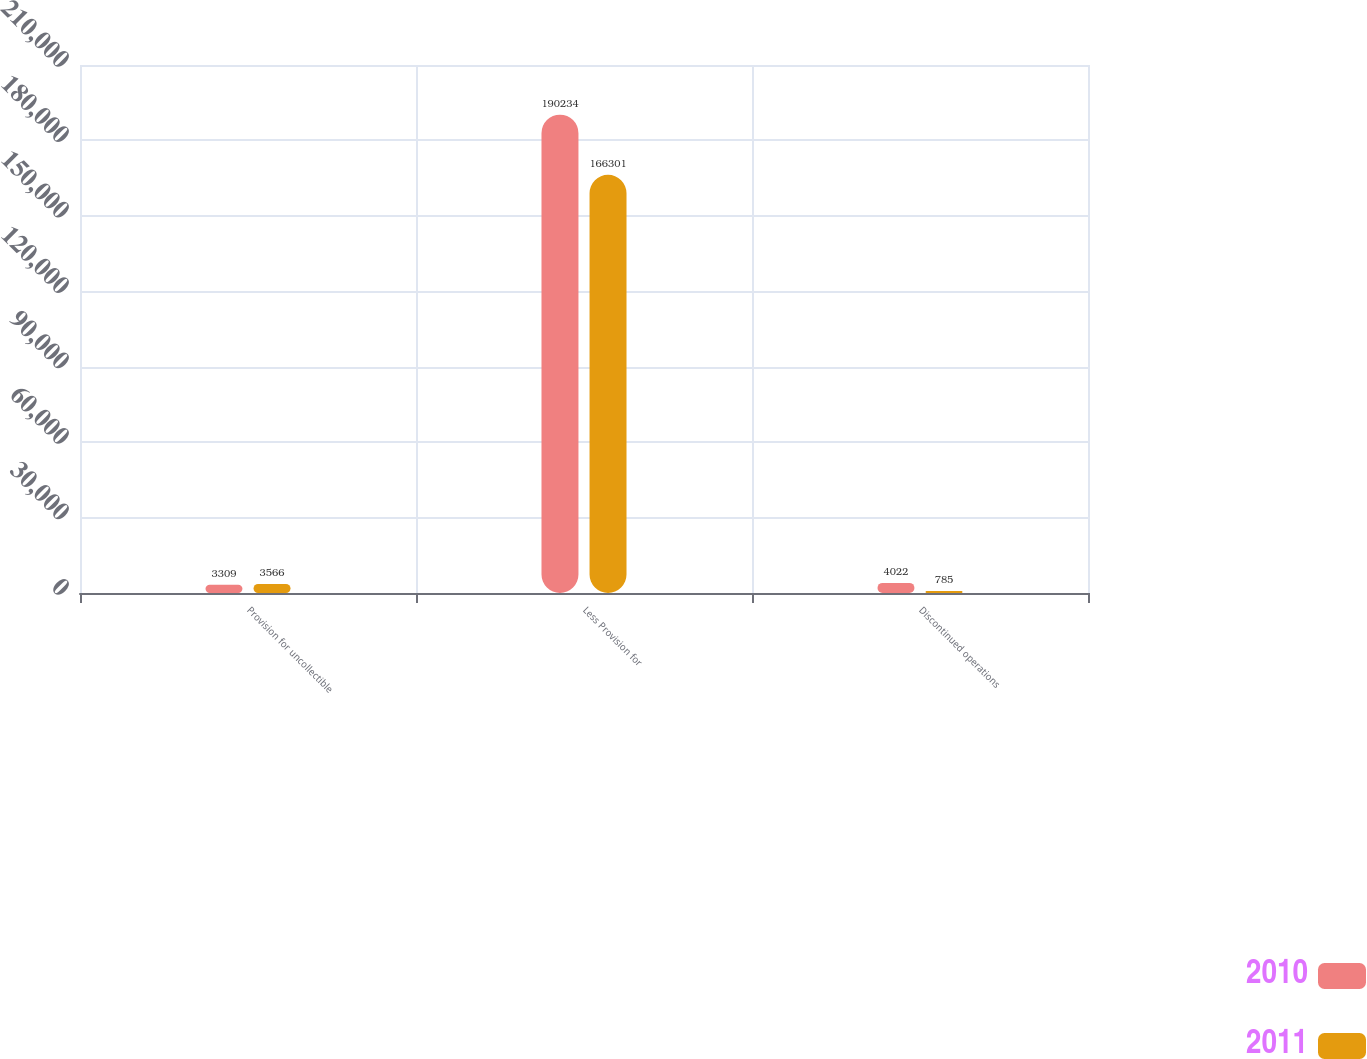Convert chart to OTSL. <chart><loc_0><loc_0><loc_500><loc_500><stacked_bar_chart><ecel><fcel>Provision for uncollectible<fcel>Less Provision for<fcel>Discontinued operations<nl><fcel>2010<fcel>3309<fcel>190234<fcel>4022<nl><fcel>2011<fcel>3566<fcel>166301<fcel>785<nl></chart> 